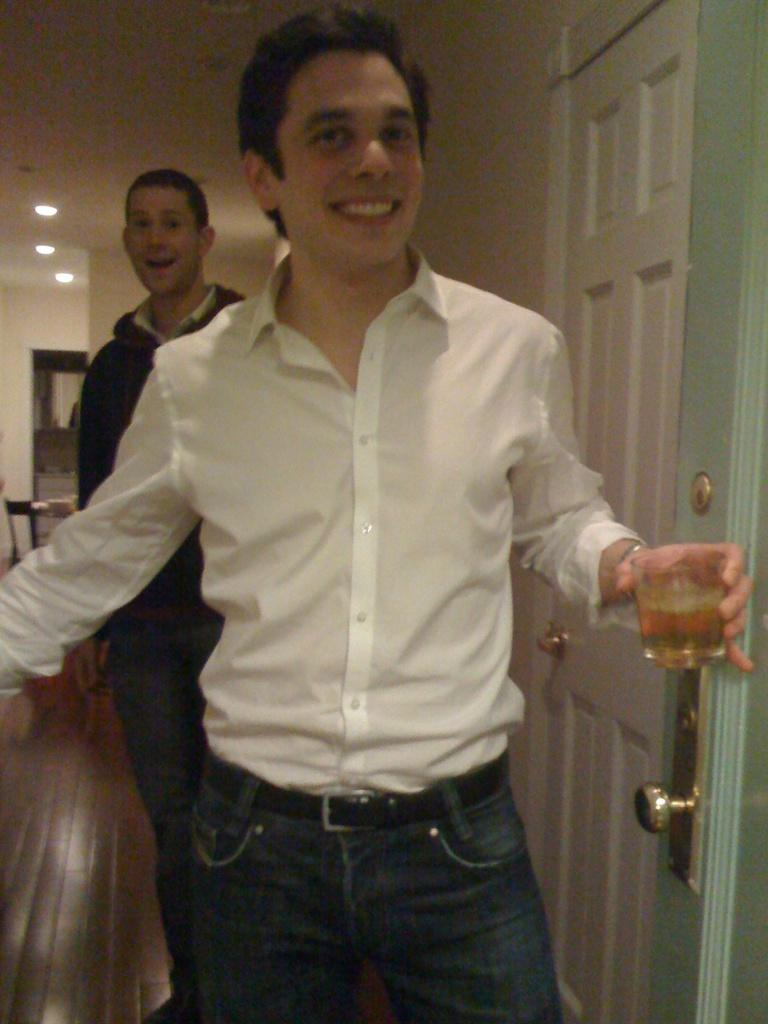Who is present in the image? There are men in the image. What is the facial expression of the men? The men are smiling. What is one man holding in his hand? One man is holding a glass in his hand. What can be seen on the ceiling in the image? There are lights on the ceiling in the image. What architectural feature is visible on the side in the image? There is a door on the side in the image. How many dogs are present in the image? There are no dogs present in the image. Is there a slope visible in the image? There is no slope visible in the image. 